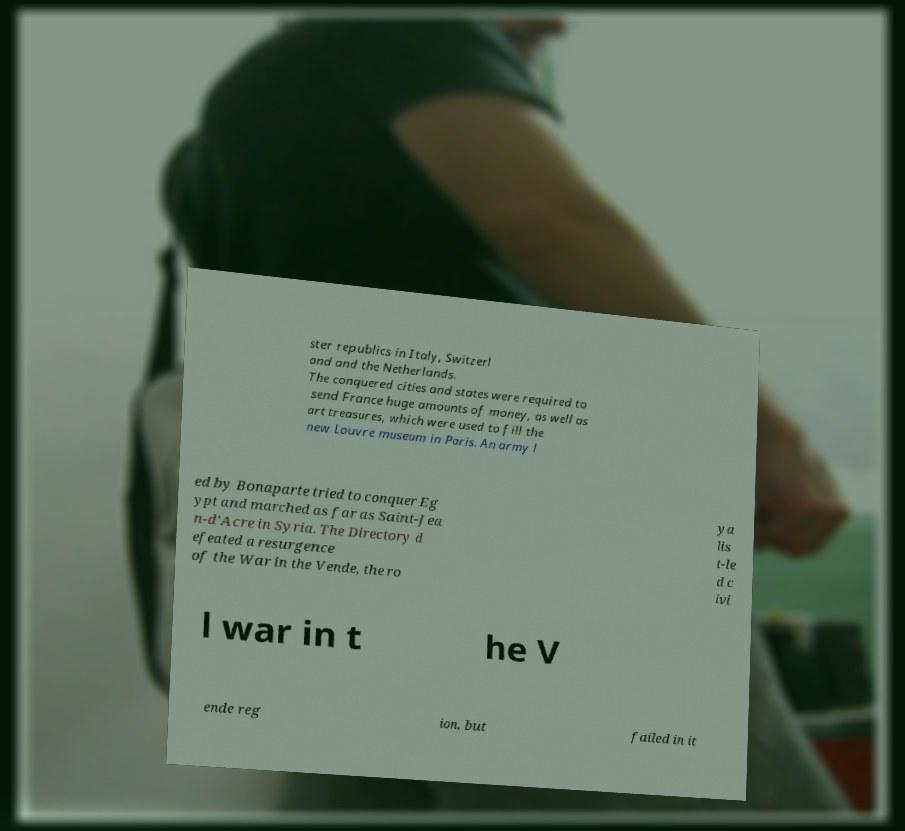For documentation purposes, I need the text within this image transcribed. Could you provide that? ster republics in Italy, Switzerl and and the Netherlands. The conquered cities and states were required to send France huge amounts of money, as well as art treasures, which were used to fill the new Louvre museum in Paris. An army l ed by Bonaparte tried to conquer Eg ypt and marched as far as Saint-Jea n-d'Acre in Syria. The Directory d efeated a resurgence of the War in the Vende, the ro ya lis t-le d c ivi l war in t he V ende reg ion, but failed in it 